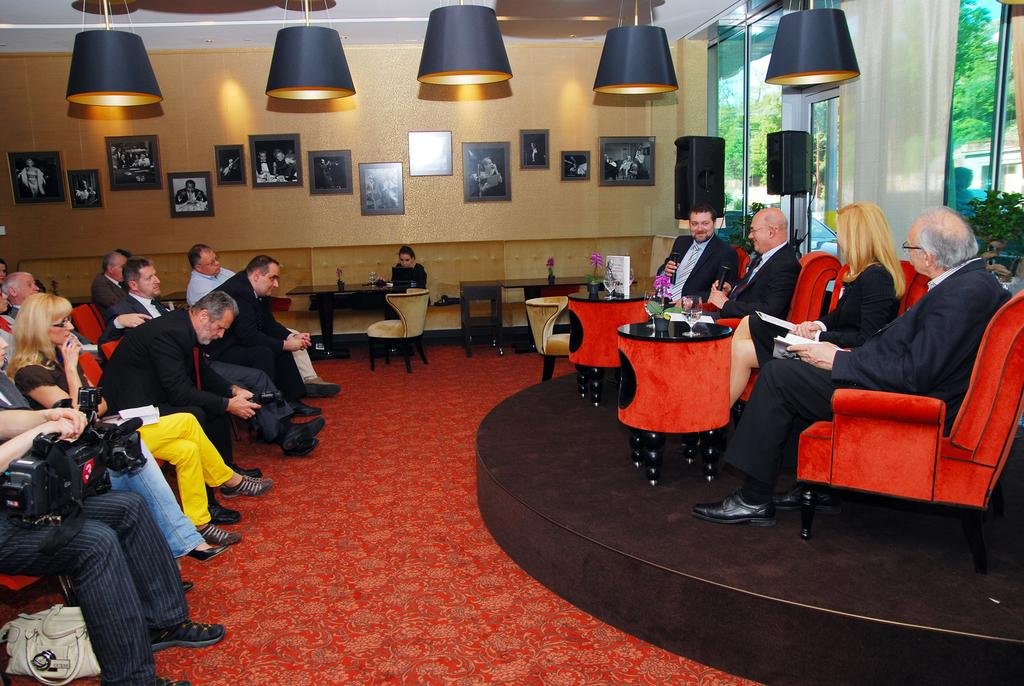What is the color of the chair that the person is sitting on in the image? The chair is red. What objects are present in the image that people might use for placing items or eating? There are tables in the image. What can be observed about the people in relation to the person sitting in the red chair? There is a group of people sitting in front of the person in the red chair. What type of treatment is being administered to the person's toes in the image? There is no indication of any treatment being administered to anyone's toes in the image. What kind of yam is being served on the tables in the image? There is no yam present in the image; the tables are not shown to have any food items on them. 